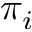<formula> <loc_0><loc_0><loc_500><loc_500>\pi _ { i }</formula> 